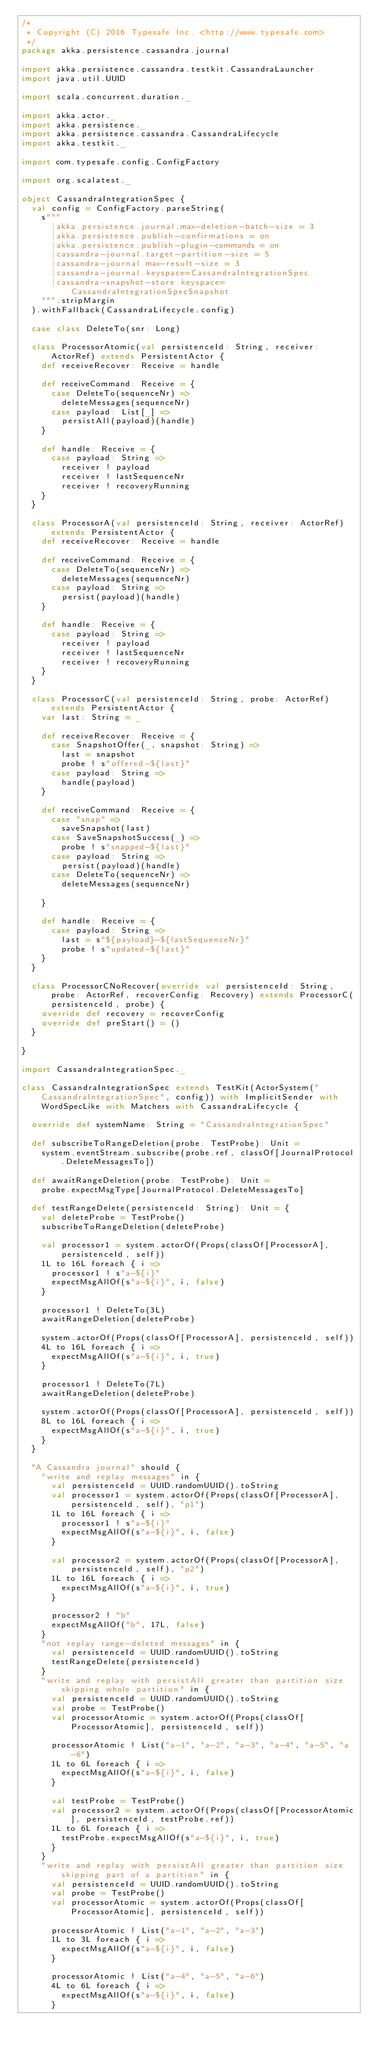<code> <loc_0><loc_0><loc_500><loc_500><_Scala_>/*
 * Copyright (C) 2016 Typesafe Inc. <http://www.typesafe.com>
 */
package akka.persistence.cassandra.journal

import akka.persistence.cassandra.testkit.CassandraLauncher
import java.util.UUID

import scala.concurrent.duration._

import akka.actor._
import akka.persistence._
import akka.persistence.cassandra.CassandraLifecycle
import akka.testkit._

import com.typesafe.config.ConfigFactory

import org.scalatest._

object CassandraIntegrationSpec {
  val config = ConfigFactory.parseString(
    s"""
      |akka.persistence.journal.max-deletion-batch-size = 3
      |akka.persistence.publish-confirmations = on
      |akka.persistence.publish-plugin-commands = on
      |cassandra-journal.target-partition-size = 5
      |cassandra-journal.max-result-size = 3
      |cassandra-journal.keyspace=CassandraIntegrationSpec
      |cassandra-snapshot-store.keyspace=CassandraIntegrationSpecSnapshot
    """.stripMargin
  ).withFallback(CassandraLifecycle.config)

  case class DeleteTo(snr: Long)

  class ProcessorAtomic(val persistenceId: String, receiver: ActorRef) extends PersistentActor {
    def receiveRecover: Receive = handle

    def receiveCommand: Receive = {
      case DeleteTo(sequenceNr) =>
        deleteMessages(sequenceNr)
      case payload: List[_] =>
        persistAll(payload)(handle)
    }

    def handle: Receive = {
      case payload: String =>
        receiver ! payload
        receiver ! lastSequenceNr
        receiver ! recoveryRunning
    }
  }

  class ProcessorA(val persistenceId: String, receiver: ActorRef) extends PersistentActor {
    def receiveRecover: Receive = handle

    def receiveCommand: Receive = {
      case DeleteTo(sequenceNr) =>
        deleteMessages(sequenceNr)
      case payload: String =>
        persist(payload)(handle)
    }

    def handle: Receive = {
      case payload: String =>
        receiver ! payload
        receiver ! lastSequenceNr
        receiver ! recoveryRunning
    }
  }

  class ProcessorC(val persistenceId: String, probe: ActorRef) extends PersistentActor {
    var last: String = _

    def receiveRecover: Receive = {
      case SnapshotOffer(_, snapshot: String) =>
        last = snapshot
        probe ! s"offered-${last}"
      case payload: String =>
        handle(payload)
    }

    def receiveCommand: Receive = {
      case "snap" =>
        saveSnapshot(last)
      case SaveSnapshotSuccess(_) =>
        probe ! s"snapped-${last}"
      case payload: String =>
        persist(payload)(handle)
      case DeleteTo(sequenceNr) =>
        deleteMessages(sequenceNr)

    }

    def handle: Receive = {
      case payload: String =>
        last = s"${payload}-${lastSequenceNr}"
        probe ! s"updated-${last}"
    }
  }

  class ProcessorCNoRecover(override val persistenceId: String, probe: ActorRef, recoverConfig: Recovery) extends ProcessorC(persistenceId, probe) {
    override def recovery = recoverConfig
    override def preStart() = ()
  }

}

import CassandraIntegrationSpec._

class CassandraIntegrationSpec extends TestKit(ActorSystem("CassandraIntegrationSpec", config)) with ImplicitSender with WordSpecLike with Matchers with CassandraLifecycle {

  override def systemName: String = "CassandraIntegrationSpec"

  def subscribeToRangeDeletion(probe: TestProbe): Unit =
    system.eventStream.subscribe(probe.ref, classOf[JournalProtocol.DeleteMessagesTo])

  def awaitRangeDeletion(probe: TestProbe): Unit =
    probe.expectMsgType[JournalProtocol.DeleteMessagesTo]

  def testRangeDelete(persistenceId: String): Unit = {
    val deleteProbe = TestProbe()
    subscribeToRangeDeletion(deleteProbe)

    val processor1 = system.actorOf(Props(classOf[ProcessorA], persistenceId, self))
    1L to 16L foreach { i =>
      processor1 ! s"a-${i}"
      expectMsgAllOf(s"a-${i}", i, false)
    }

    processor1 ! DeleteTo(3L)
    awaitRangeDeletion(deleteProbe)

    system.actorOf(Props(classOf[ProcessorA], persistenceId, self))
    4L to 16L foreach { i =>
      expectMsgAllOf(s"a-${i}", i, true)
    }

    processor1 ! DeleteTo(7L)
    awaitRangeDeletion(deleteProbe)

    system.actorOf(Props(classOf[ProcessorA], persistenceId, self))
    8L to 16L foreach { i =>
      expectMsgAllOf(s"a-${i}", i, true)
    }
  }

  "A Cassandra journal" should {
    "write and replay messages" in {
      val persistenceId = UUID.randomUUID().toString
      val processor1 = system.actorOf(Props(classOf[ProcessorA], persistenceId, self), "p1")
      1L to 16L foreach { i =>
        processor1 ! s"a-${i}"
        expectMsgAllOf(s"a-${i}", i, false)
      }

      val processor2 = system.actorOf(Props(classOf[ProcessorA], persistenceId, self), "p2")
      1L to 16L foreach { i =>
        expectMsgAllOf(s"a-${i}", i, true)
      }

      processor2 ! "b"
      expectMsgAllOf("b", 17L, false)
    }
    "not replay range-deleted messages" in {
      val persistenceId = UUID.randomUUID().toString
      testRangeDelete(persistenceId)
    }
    "write and replay with persistAll greater than partition size skipping whole partition" in {
      val persistenceId = UUID.randomUUID().toString
      val probe = TestProbe()
      val processorAtomic = system.actorOf(Props(classOf[ProcessorAtomic], persistenceId, self))

      processorAtomic ! List("a-1", "a-2", "a-3", "a-4", "a-5", "a-6")
      1L to 6L foreach { i =>
        expectMsgAllOf(s"a-${i}", i, false)
      }

      val testProbe = TestProbe()
      val processor2 = system.actorOf(Props(classOf[ProcessorAtomic], persistenceId, testProbe.ref))
      1L to 6L foreach { i =>
        testProbe.expectMsgAllOf(s"a-${i}", i, true)
      }
    }
    "write and replay with persistAll greater than partition size skipping part of a partition" in {
      val persistenceId = UUID.randomUUID().toString
      val probe = TestProbe()
      val processorAtomic = system.actorOf(Props(classOf[ProcessorAtomic], persistenceId, self))

      processorAtomic ! List("a-1", "a-2", "a-3")
      1L to 3L foreach { i =>
        expectMsgAllOf(s"a-${i}", i, false)
      }

      processorAtomic ! List("a-4", "a-5", "a-6")
      4L to 6L foreach { i =>
        expectMsgAllOf(s"a-${i}", i, false)
      }
</code> 